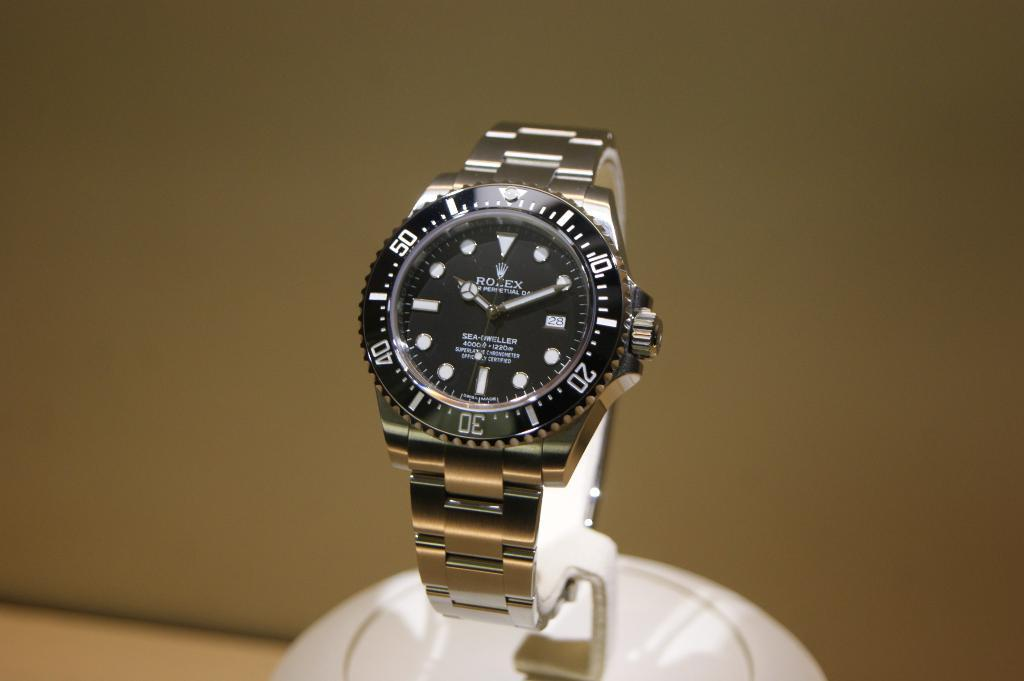What object is the main focus of the image? There is a watch in the image. How is the watch positioned in the image? The watch is on a white-colored holder. What can be seen behind the watch in the image? There is a background visible in the image. What is visible below the watch in the image? The ground is visible in the image. What type of verse can be seen written on the watch in the image? There is no verse written on the watch in the image; it is a watch without any text or inscriptions. 